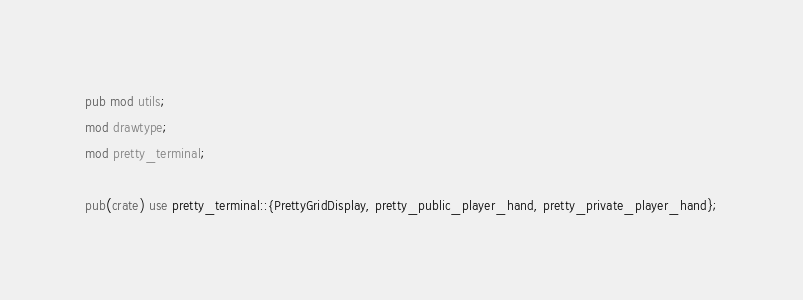Convert code to text. <code><loc_0><loc_0><loc_500><loc_500><_Rust_>pub mod utils;
mod drawtype;
mod pretty_terminal;

pub(crate) use pretty_terminal::{PrettyGridDisplay, pretty_public_player_hand, pretty_private_player_hand};
</code> 